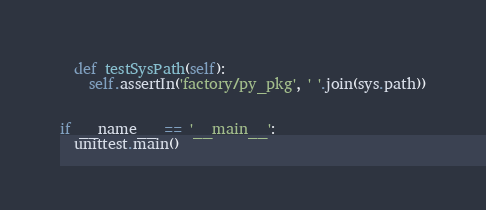Convert code to text. <code><loc_0><loc_0><loc_500><loc_500><_Python_>
  def testSysPath(self):
    self.assertIn('factory/py_pkg', ' '.join(sys.path))


if __name__ == '__main__':
  unittest.main()
</code> 